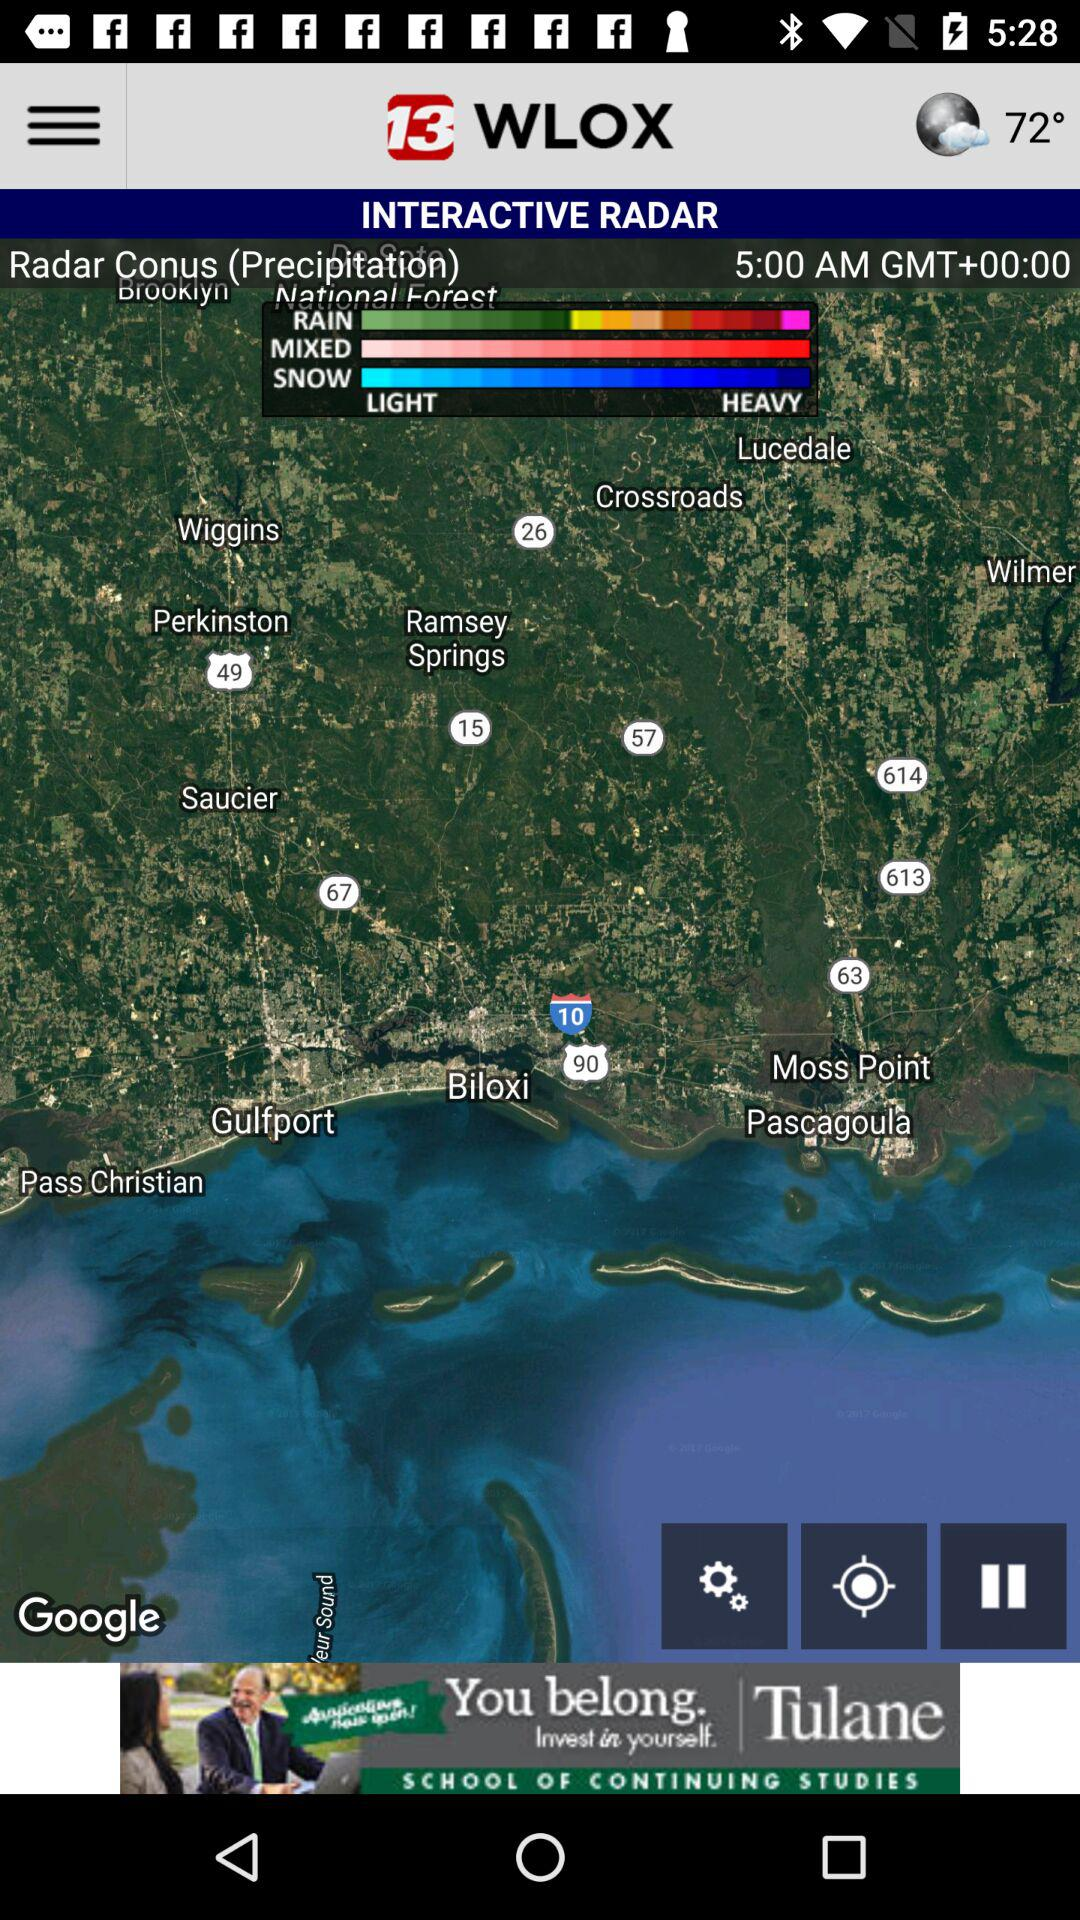What is the name of the application? The application name is "13 WLOX". 